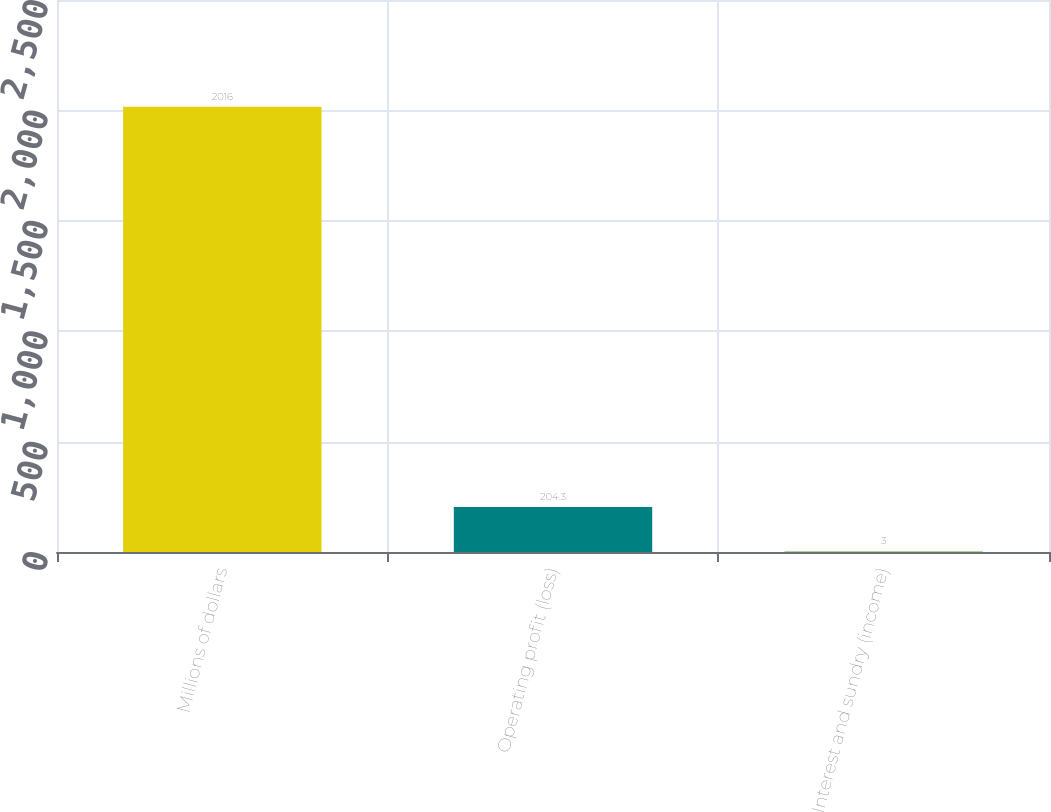<chart> <loc_0><loc_0><loc_500><loc_500><bar_chart><fcel>Millions of dollars<fcel>Operating profit (loss)<fcel>Interest and sundry (income)<nl><fcel>2016<fcel>204.3<fcel>3<nl></chart> 